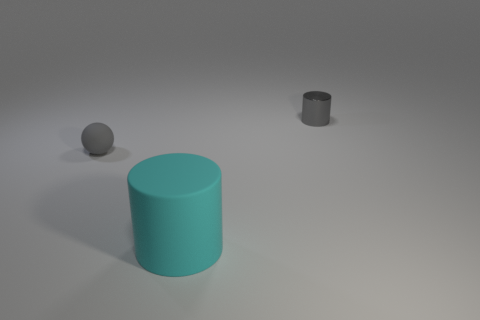Are there any other things that have the same size as the cyan matte cylinder?
Ensure brevity in your answer.  No. Does the tiny sphere have the same material as the cyan object?
Make the answer very short. Yes. There is a gray thing in front of the gray shiny object; does it have the same size as the cylinder that is left of the metal thing?
Offer a terse response. No. Are there fewer things than big rubber cylinders?
Your response must be concise. No. What number of metallic objects are small gray balls or small things?
Give a very brief answer. 1. Is there a cylinder that is behind the small object that is on the left side of the large thing?
Ensure brevity in your answer.  Yes. Is the material of the object in front of the small gray matte ball the same as the tiny gray cylinder?
Your response must be concise. No. What number of other objects are the same color as the large cylinder?
Give a very brief answer. 0. Do the big cylinder and the small sphere have the same color?
Offer a very short reply. No. What is the size of the cylinder to the left of the object to the right of the cyan cylinder?
Your response must be concise. Large. 